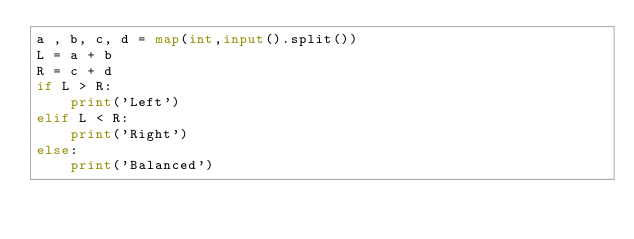Convert code to text. <code><loc_0><loc_0><loc_500><loc_500><_Python_>a , b, c, d = map(int,input().split())
L = a + b
R = c + d
if L > R:
    print('Left')
elif L < R:
    print('Right')
else:
    print('Balanced')</code> 